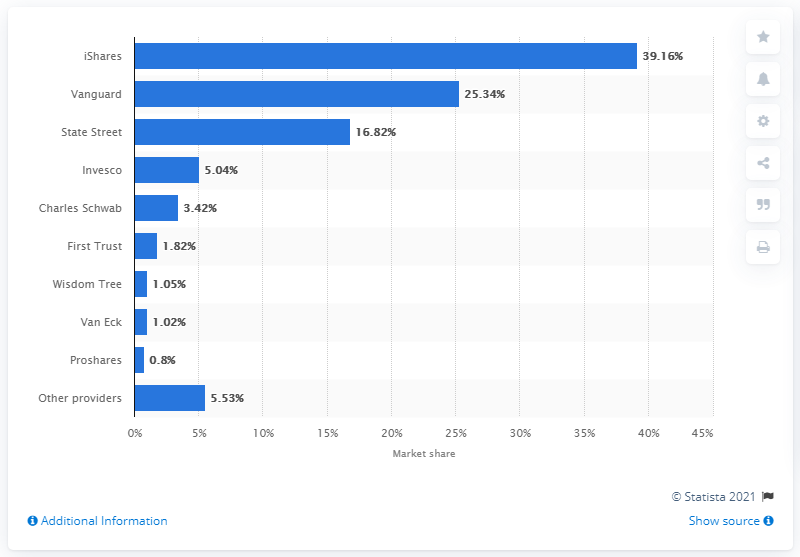List a handful of essential elements in this visual. State Street was the third largest ETP provider worldwide. State Street was the third largest ETP provider worldwide. 